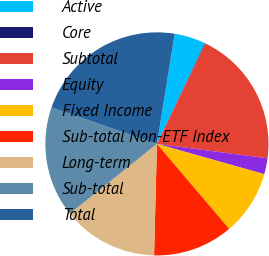Convert chart to OTSL. <chart><loc_0><loc_0><loc_500><loc_500><pie_chart><fcel>Active<fcel>Core<fcel>Subtotal<fcel>Equity<fcel>Fixed Income<fcel>Sub-total Non-ETF Index<fcel>Long-term<fcel>Sub-total<fcel>Total<nl><fcel>4.53%<fcel>0.1%<fcel>19.89%<fcel>2.31%<fcel>9.41%<fcel>11.62%<fcel>13.84%<fcel>16.05%<fcel>22.25%<nl></chart> 